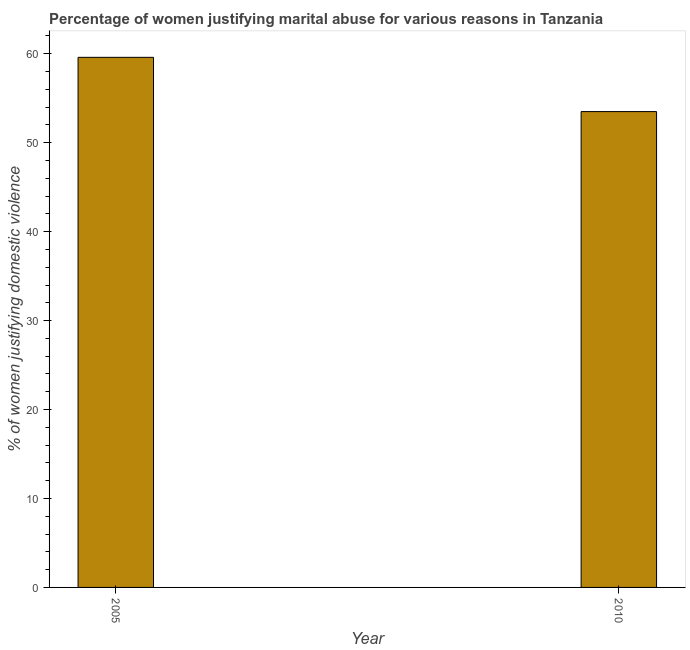Does the graph contain any zero values?
Provide a succinct answer. No. What is the title of the graph?
Provide a succinct answer. Percentage of women justifying marital abuse for various reasons in Tanzania. What is the label or title of the Y-axis?
Offer a very short reply. % of women justifying domestic violence. What is the percentage of women justifying marital abuse in 2005?
Your answer should be compact. 59.6. Across all years, what is the maximum percentage of women justifying marital abuse?
Your answer should be very brief. 59.6. Across all years, what is the minimum percentage of women justifying marital abuse?
Keep it short and to the point. 53.5. In which year was the percentage of women justifying marital abuse minimum?
Provide a succinct answer. 2010. What is the sum of the percentage of women justifying marital abuse?
Ensure brevity in your answer.  113.1. What is the average percentage of women justifying marital abuse per year?
Your answer should be compact. 56.55. What is the median percentage of women justifying marital abuse?
Keep it short and to the point. 56.55. In how many years, is the percentage of women justifying marital abuse greater than 12 %?
Give a very brief answer. 2. Do a majority of the years between 2010 and 2005 (inclusive) have percentage of women justifying marital abuse greater than 24 %?
Offer a terse response. No. What is the ratio of the percentage of women justifying marital abuse in 2005 to that in 2010?
Offer a terse response. 1.11. In how many years, is the percentage of women justifying marital abuse greater than the average percentage of women justifying marital abuse taken over all years?
Your answer should be compact. 1. How many bars are there?
Keep it short and to the point. 2. How many years are there in the graph?
Your answer should be compact. 2. What is the % of women justifying domestic violence in 2005?
Give a very brief answer. 59.6. What is the % of women justifying domestic violence in 2010?
Offer a terse response. 53.5. What is the difference between the % of women justifying domestic violence in 2005 and 2010?
Offer a very short reply. 6.1. What is the ratio of the % of women justifying domestic violence in 2005 to that in 2010?
Provide a short and direct response. 1.11. 